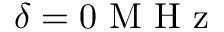<formula> <loc_0><loc_0><loc_500><loc_500>\delta = 0 M H z</formula> 